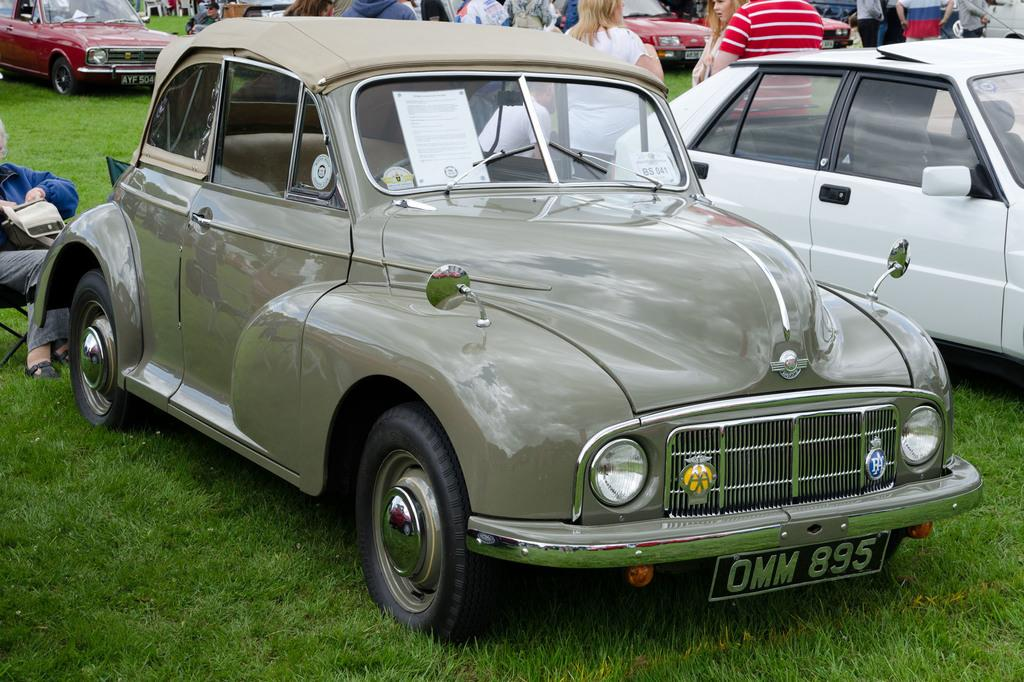How many people are in the image? There are people in the image, but the exact number is not specified. What is the position of one of the people in the image? One person is sitting on a chair in the image. What type of vehicles can be seen in the image? There are cars in the image. What type of natural environment is visible in the image? There is grass visible in the image. Can you see a crown on the person sitting on the chair in the image? No, there is no crown visible on the person sitting on the chair in the image. What type of plastic objects can be seen in the image? There is no mention of plastic objects in the image, so we cannot answer this question. 